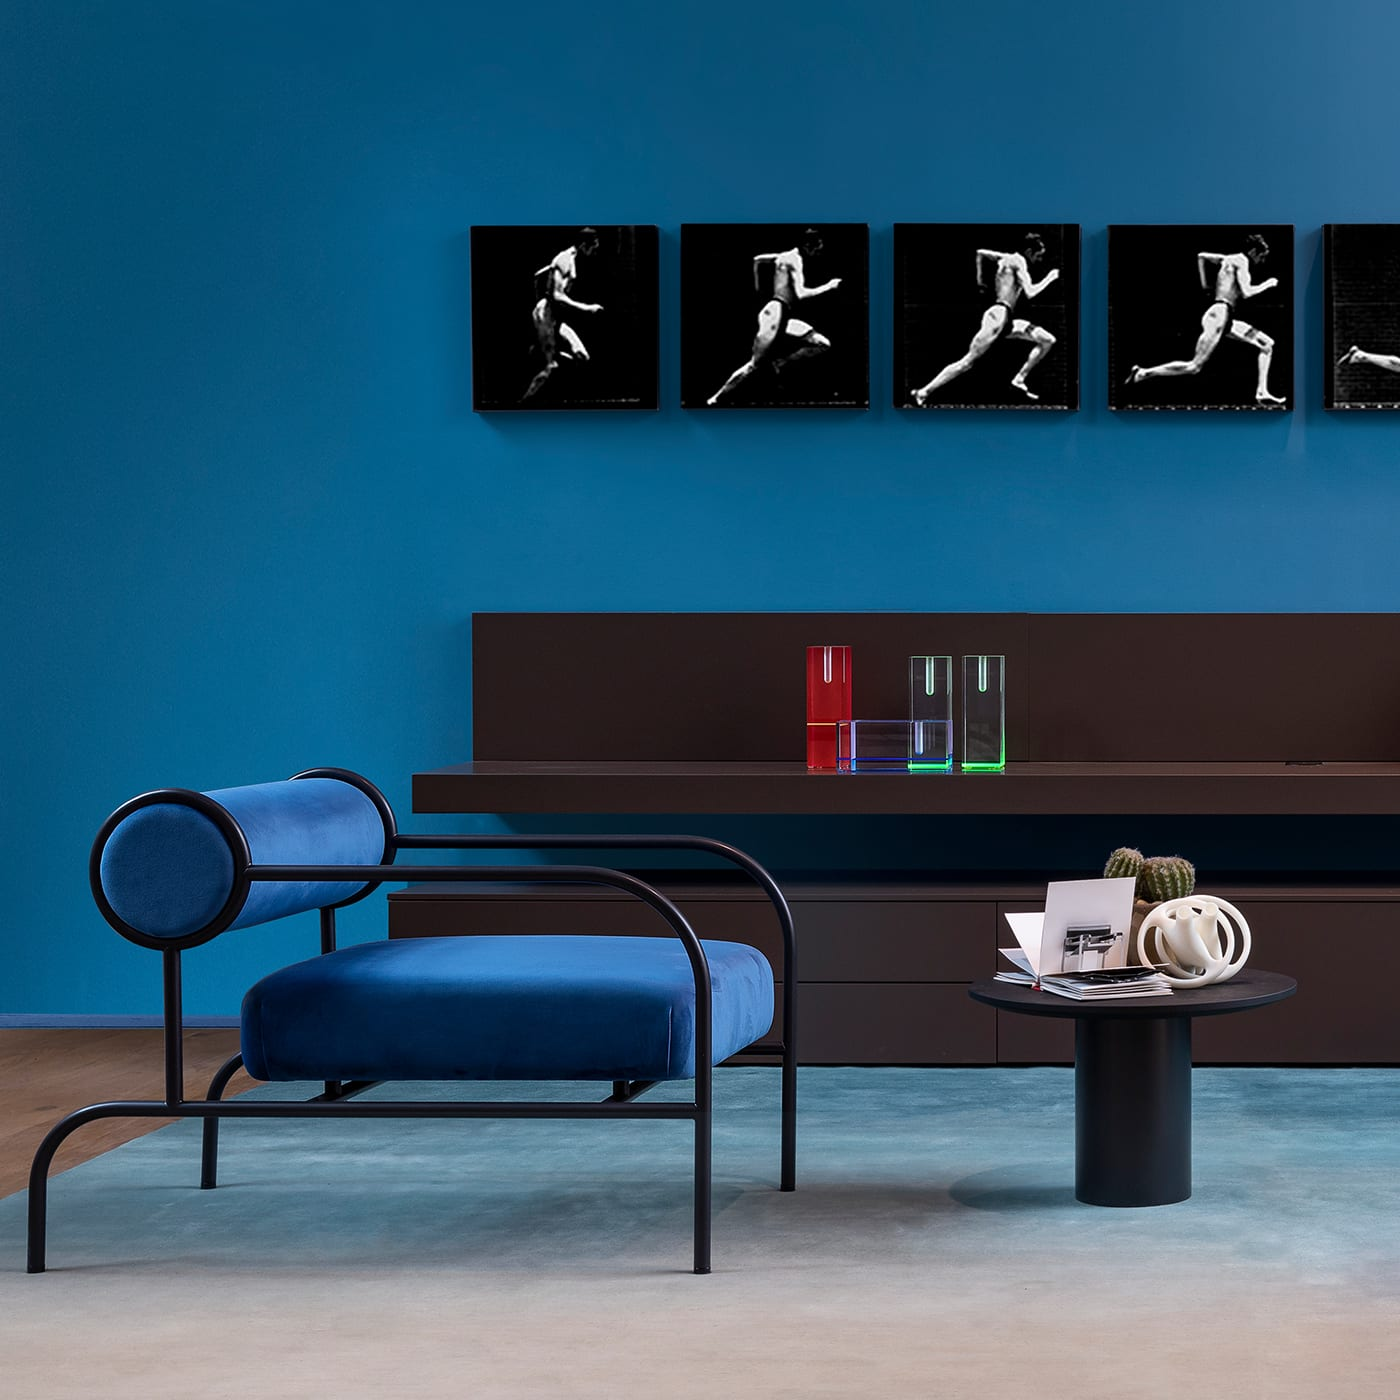Can you describe the artwork on the wall? The artwork consists of a sequence of black and white photographs displayed in a linear arrangement. Each frame captures a different pose of a dancer in motion, illustrating a dynamic and fluid performance spread across the series. Does the art seem to tell a story? Yes, the sequence of photographs suggests a narrative of movement and dance, portraying a fluid progression of forms that might represent a single dance routine, capturing the elegance and energy of the dancer. 